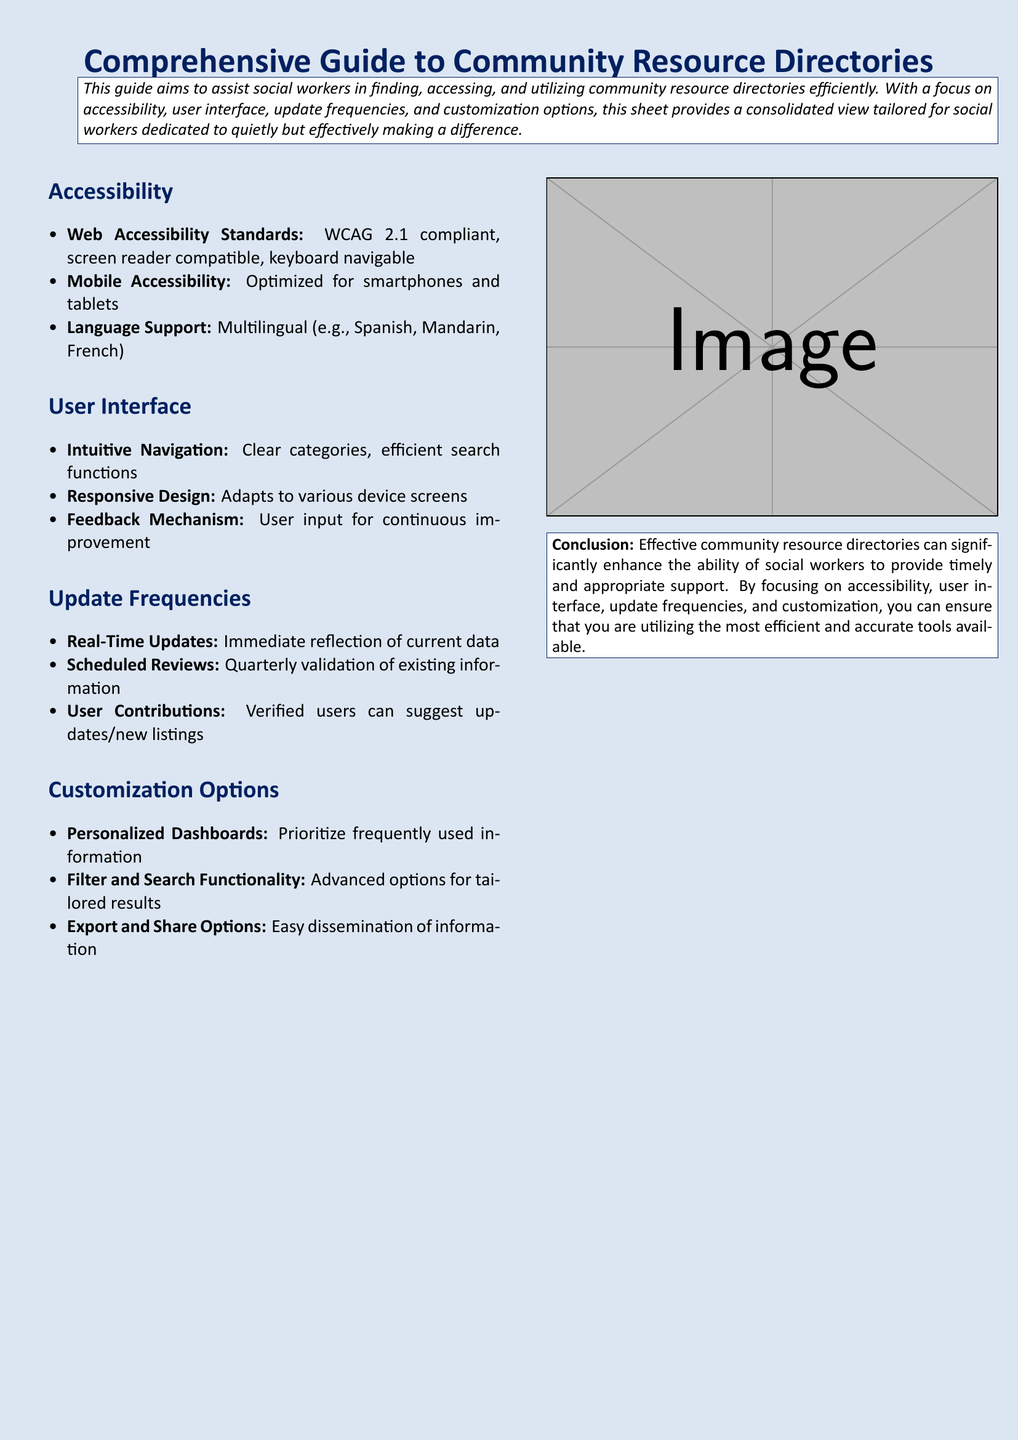What is the primary focus of the guide? The primary focus of the guide is to assist social workers in finding and utilizing community resource directories efficiently.
Answer: Assist social workers What accessibility standard is mentioned in the document? The document specifies that the web accessibility standard is WCAG 2.1 compliant.
Answer: WCAG 2.1 How often are scheduled reviews conducted for updates? The scheduled reviews of existing information are conducted quarterly.
Answer: Quarterly What kind of support does the guide provide for language? The guide provides multilingual support, including Spanish, Mandarin, and French.
Answer: Multilingual What type of design is emphasized for user interface adaptation? The document emphasizes responsive design that adapts to various device screens.
Answer: Responsive design How does the guide allow user interaction for updates? Verified users can suggest updates or new listings to the directory.
Answer: User contributions What is offered in terms of dashboard customization? The guide offers personalized dashboards to prioritize frequently used information.
Answer: Personalized dashboards What is included in the conclusion of the guide? The conclusion states that effective community resource directories enhance social workers' ability to provide support.
Answer: Enhance ability to provide support 